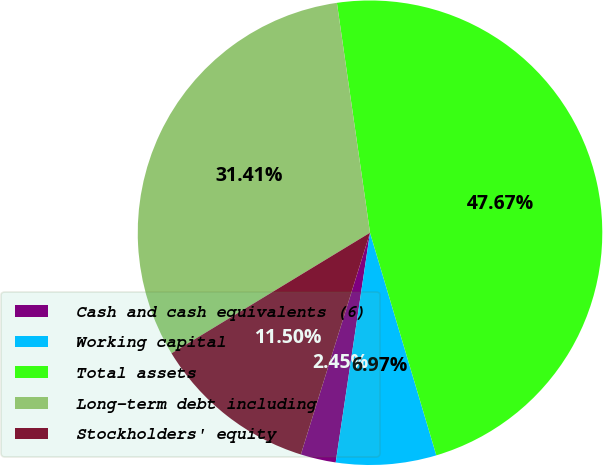Convert chart to OTSL. <chart><loc_0><loc_0><loc_500><loc_500><pie_chart><fcel>Cash and cash equivalents (6)<fcel>Working capital<fcel>Total assets<fcel>Long-term debt including<fcel>Stockholders' equity<nl><fcel>2.45%<fcel>6.97%<fcel>47.67%<fcel>31.41%<fcel>11.5%<nl></chart> 